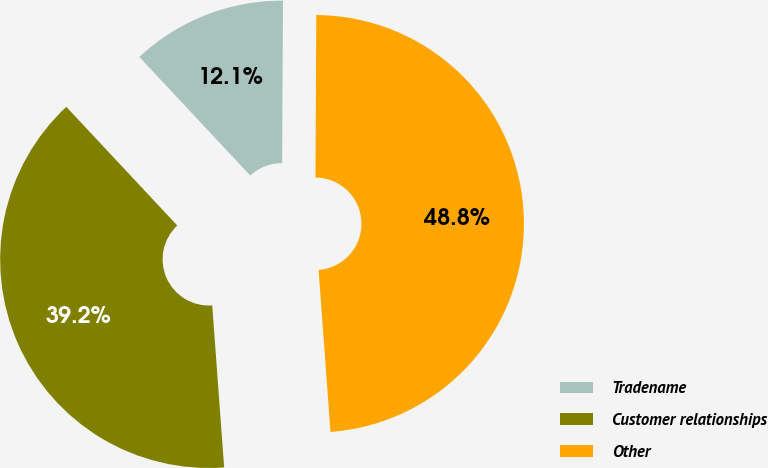<chart> <loc_0><loc_0><loc_500><loc_500><pie_chart><fcel>Tradename<fcel>Customer relationships<fcel>Other<nl><fcel>12.05%<fcel>39.2%<fcel>48.75%<nl></chart> 